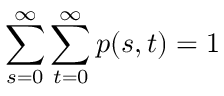Convert formula to latex. <formula><loc_0><loc_0><loc_500><loc_500>\sum _ { s = 0 } ^ { \infty } \sum _ { t = 0 } ^ { \infty } p ( s , t ) = 1</formula> 